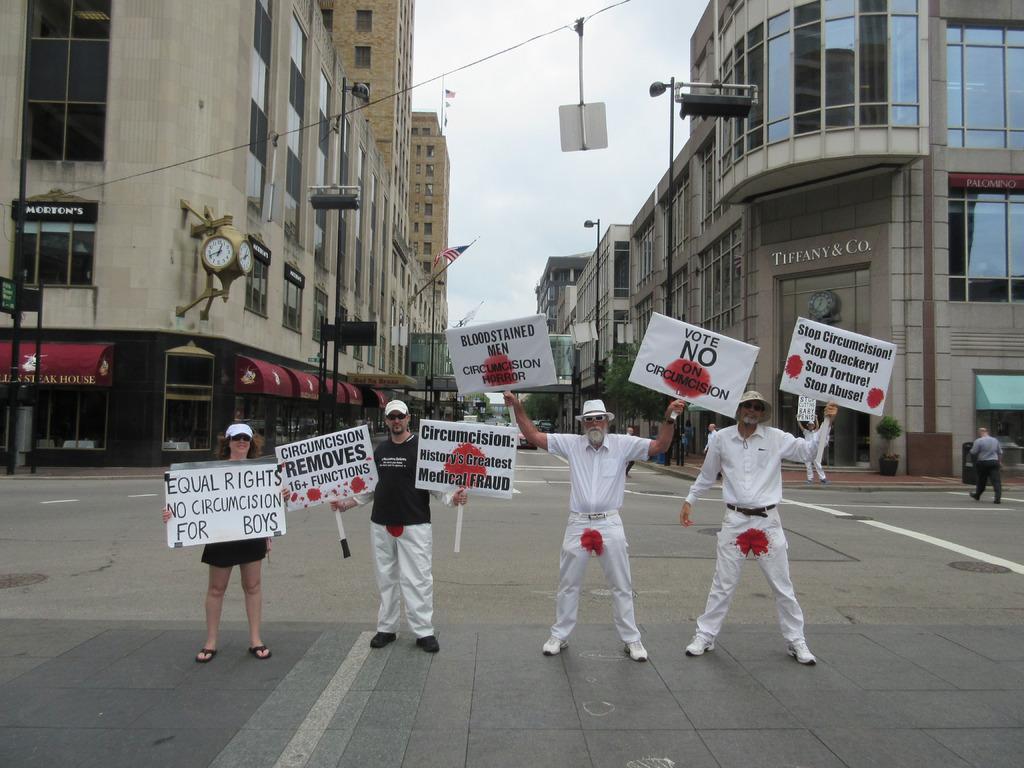In one or two sentences, can you explain what this image depicts? In this picture I can see there are a few people standing and they are holding the boards and there is something written on it. In the backdrop, there are few buildings in the backdrop with glass windows. 